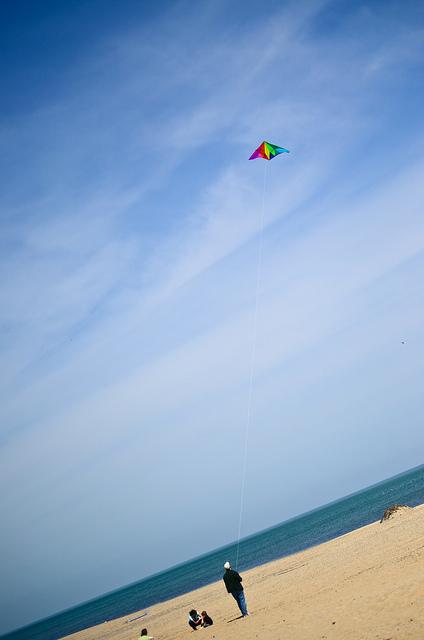Is it hot on this beach?
Answer briefly. Yes. Are the man's pants and the flag the same color?
Write a very short answer. No. Is the camera being held with correct orientation to the horizon?
Keep it brief. No. At roughly what angle is the flag in the background tilted?
Answer briefly. Right. Can you see the sun?
Write a very short answer. No. 